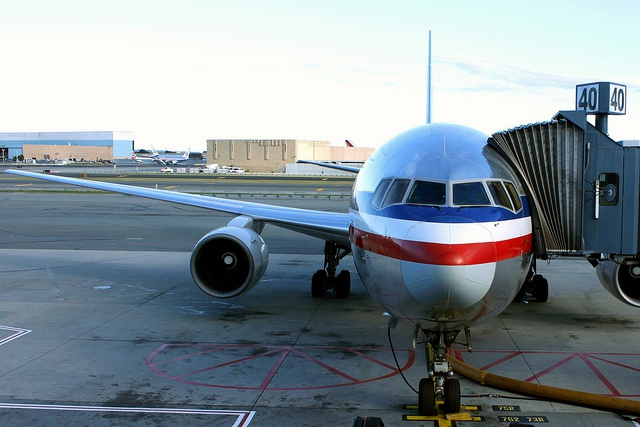Describe the objects in this image and their specific colors. I can see airplane in white, black, lightblue, and gray tones and airplane in white, lavender, lightblue, and darkgray tones in this image. 